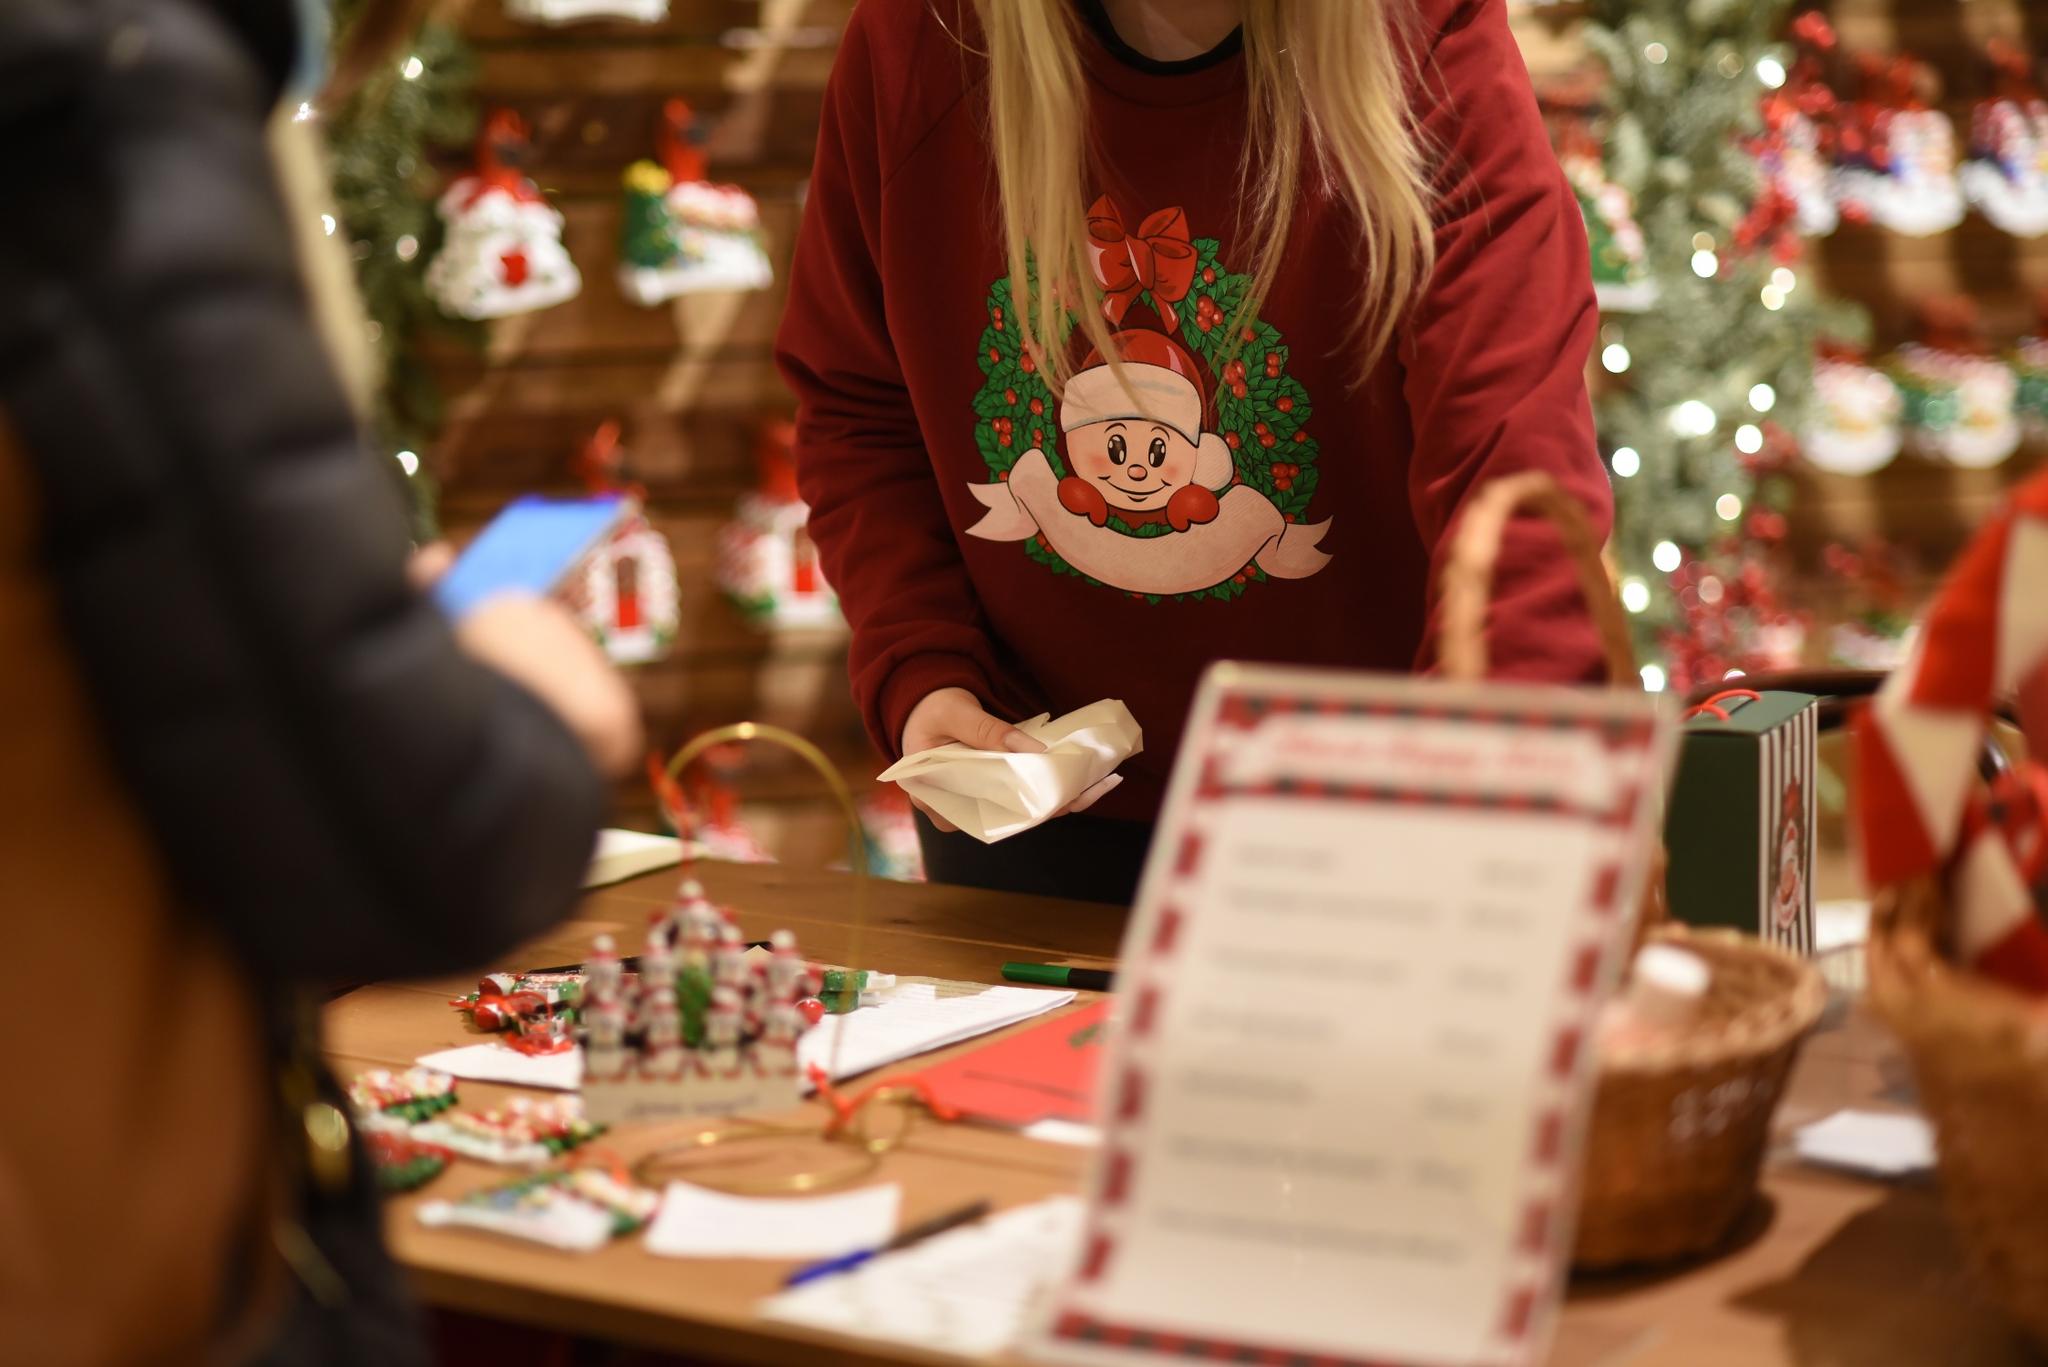How might a typical day look like for the person wrapping gifts? A typical day for the person wrapping gifts might begin early in the morning. They would arrive at the store, greeted by the scent of pine and cinnamon, signaling another day filled with festive cheer. The day starts with unboxing new decorations and arranging them neatly on the wooden counter. As customers trickle in, they assist them in selecting the perfect ornaments and trinkets. By mid-morning, the gift-wrapping station gets busy. With nimble fingers and an artistic touch, they skillfully wrap each present, adding ribbons, bows, and decorative tags to create beautifully crafted packages. The afternoon is spent balancing between helping customers and wrapping an increasing number of gifts as the festive season draws near. Each evening concludes with a sense of satisfaction, having contributed to the joy and excitement that each wrapped gift brings to someone’s day. 